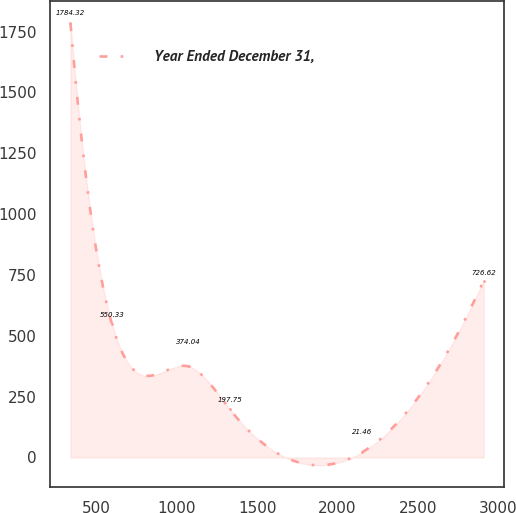Convert chart to OTSL. <chart><loc_0><loc_0><loc_500><loc_500><line_chart><ecel><fcel>Year Ended December 31,<nl><fcel>336.96<fcel>1784.32<nl><fcel>594.32<fcel>550.33<nl><fcel>1072.54<fcel>374.04<nl><fcel>1329.9<fcel>197.75<nl><fcel>2153.51<fcel>21.46<nl><fcel>2910.56<fcel>726.62<nl></chart> 